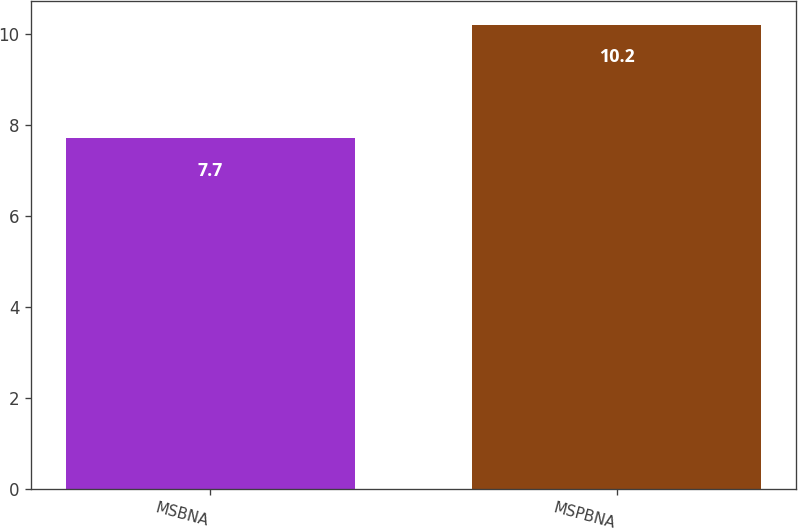Convert chart. <chart><loc_0><loc_0><loc_500><loc_500><bar_chart><fcel>MSBNA<fcel>MSPBNA<nl><fcel>7.7<fcel>10.2<nl></chart> 